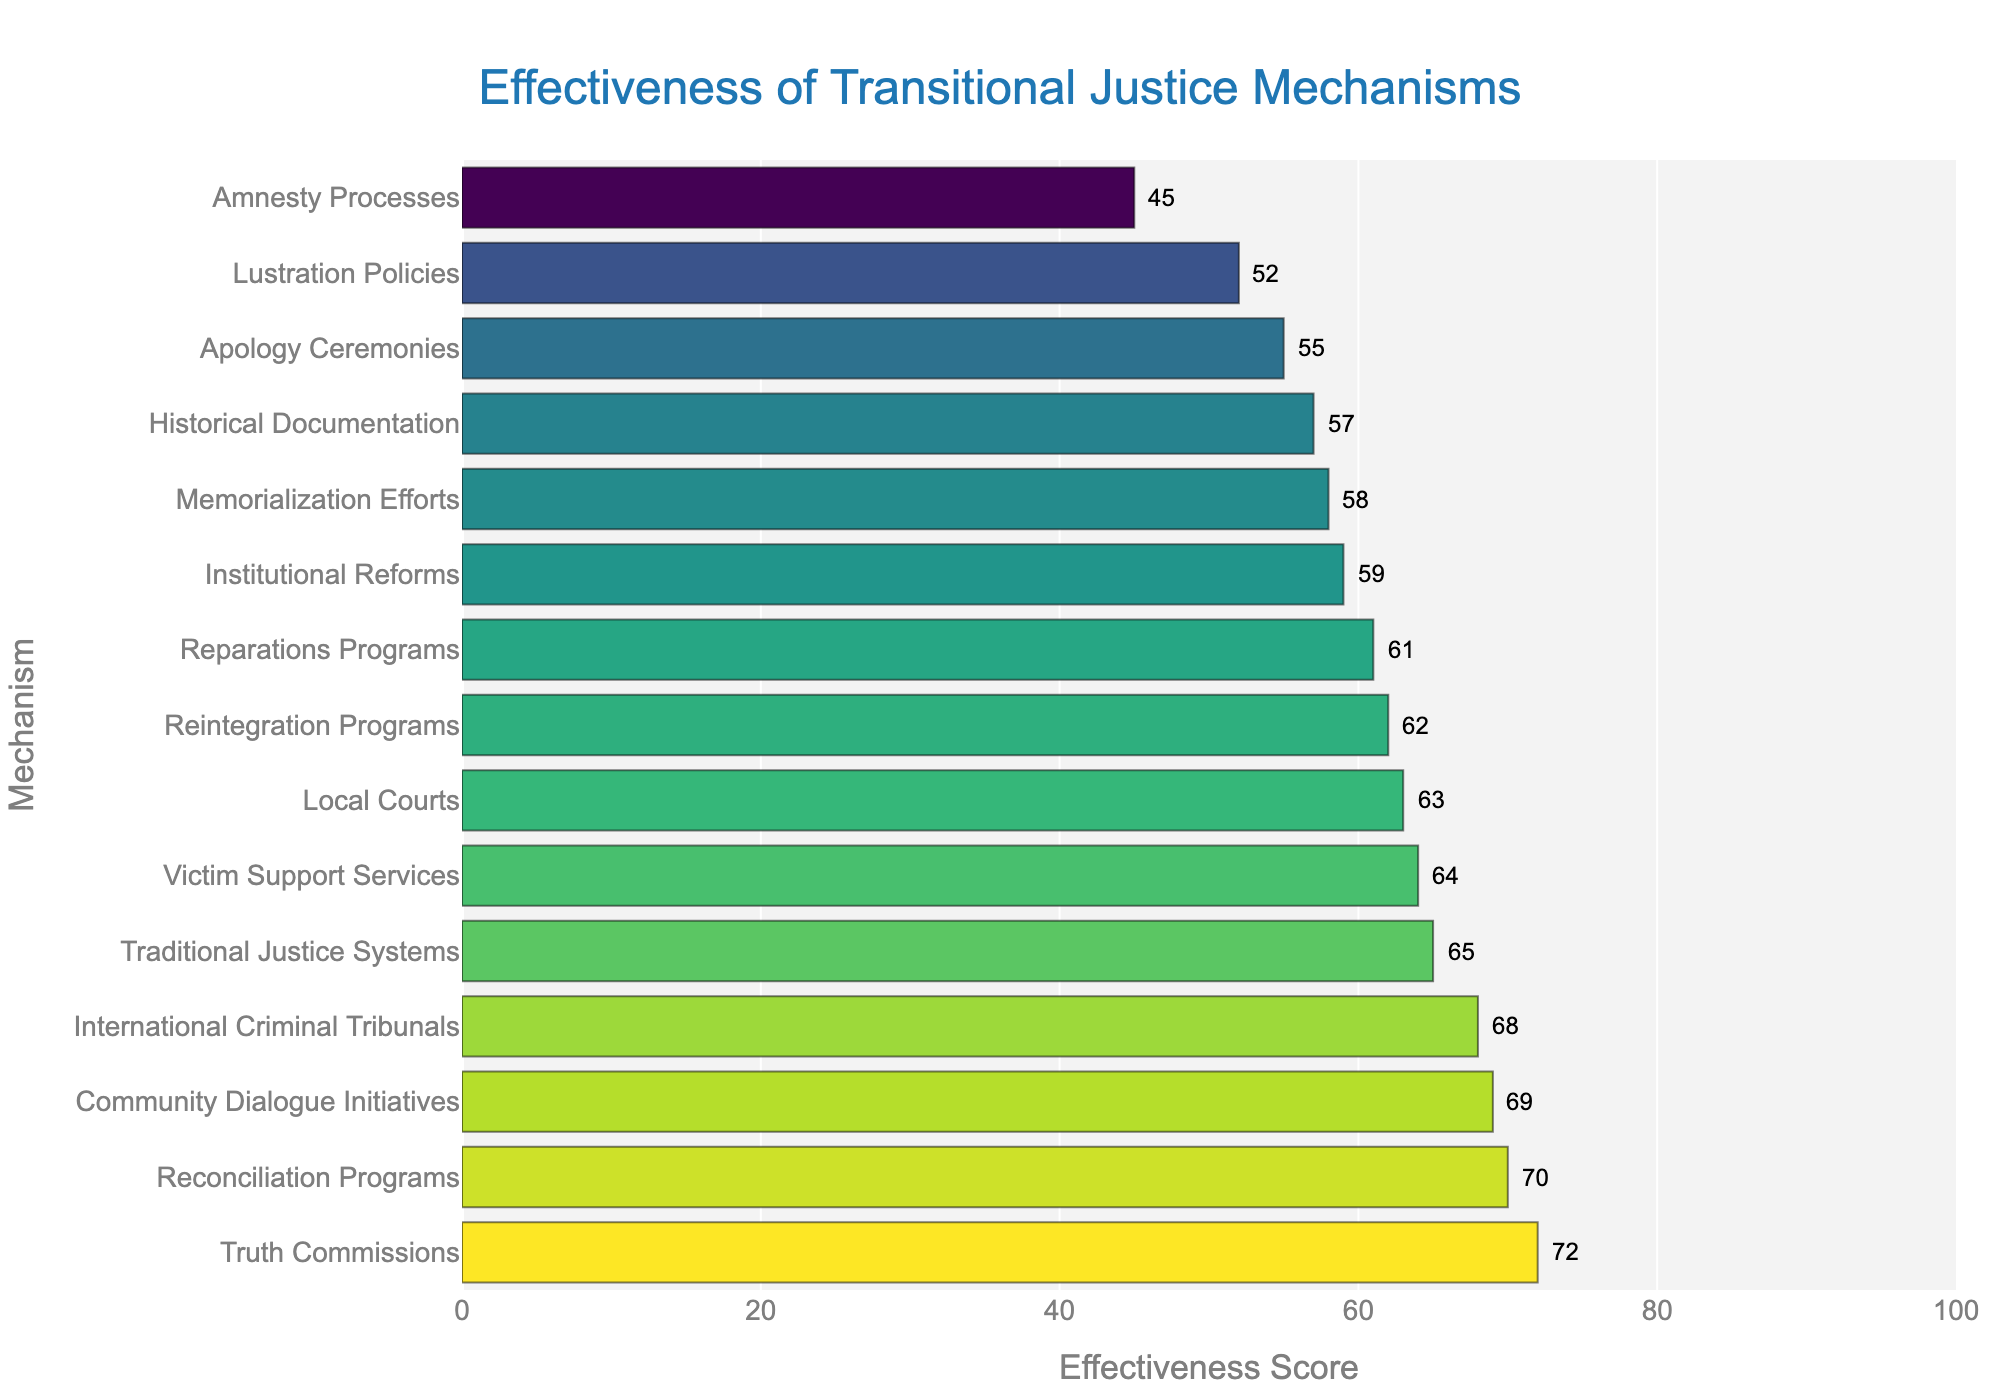Which transitional justice mechanism has the highest public perception of effectiveness? The bar representing Truth Commissions is the tallest, indicating it has the highest effectiveness score at 72.
Answer: Truth Commissions How does the effectiveness of Reconciliation Programs compare to that of Community Dialogue Initiatives? The bar for Reconciliation Programs has an effectiveness score of 70 and the bar for Community Dialogue Initiatives has an effectiveness score of 69. Reconciliation Programs is slightly higher.
Answer: Reconciliation Programs is slightly higher Which mechanisms have effectiveness scores within the 60-65 range? The bars showing effectiveness scores between 60 and 65 are Reparations Programs (61), Local Courts (63), Victim Support Services (64), and Reintegration Programs (62).
Answer: Reparations Programs, Local Courts, Victim Support Services, and Reintegration Programs What is the combined effectiveness score for Truth Commissions, International Criminal Tribunals, and Reconciliation Programs? Sum the effectiveness scores: Truth Commissions (72) + International Criminal Tribunals (68) + Reconciliation Programs (70) = 210.
Answer: 210 Which mechanism has the lowest public perception of effectiveness? The shortest bar belongs to Amnesty Processes, showing an effectiveness score of 45.
Answer: Amnesty Processes Is there a significant difference in the effectiveness scores between Apology Ceremonies and Historical Documentation? The effectiveness score for Apology Ceremonies is 55, and for Historical Documentation, it's 57. The difference is 2.
Answer: No, the difference is small (2) What is the average effectiveness score of Amnesty Processes, Memorialization Efforts, and Lustration Policies? Sum the effectiveness scores: Amnesty Processes (45) + Memorialization Efforts (58) + Lustration Policies (52) = 155. Then divide by 3: 155 / 3 ≈ 51.67.
Answer: About 51.67 Which mechanisms have an effectiveness score above 68? Mechanisms with scores above 68 are Truth Commissions (72), Reconciliation Programs (70), and Community Dialogue Initiatives (69).
Answer: Truth Commissions, Reconciliation Programs, Community Dialogue Initiatives What is the difference in effectiveness between the most effective and least effective mechanisms? The most effective mechanism is Truth Commissions with a score of 72 and the least effective is Amnesty Processes with a score of 45. The difference is 72 - 45 = 27.
Answer: 27 Which mechanisms have the closest effectiveness scores? The closest effectiveness scores are between Community Dialogue Initiatives (69) and International Criminal Tribunals (68), with a difference of 1.
Answer: Community Dialogue Initiatives and International Criminal Tribunals 